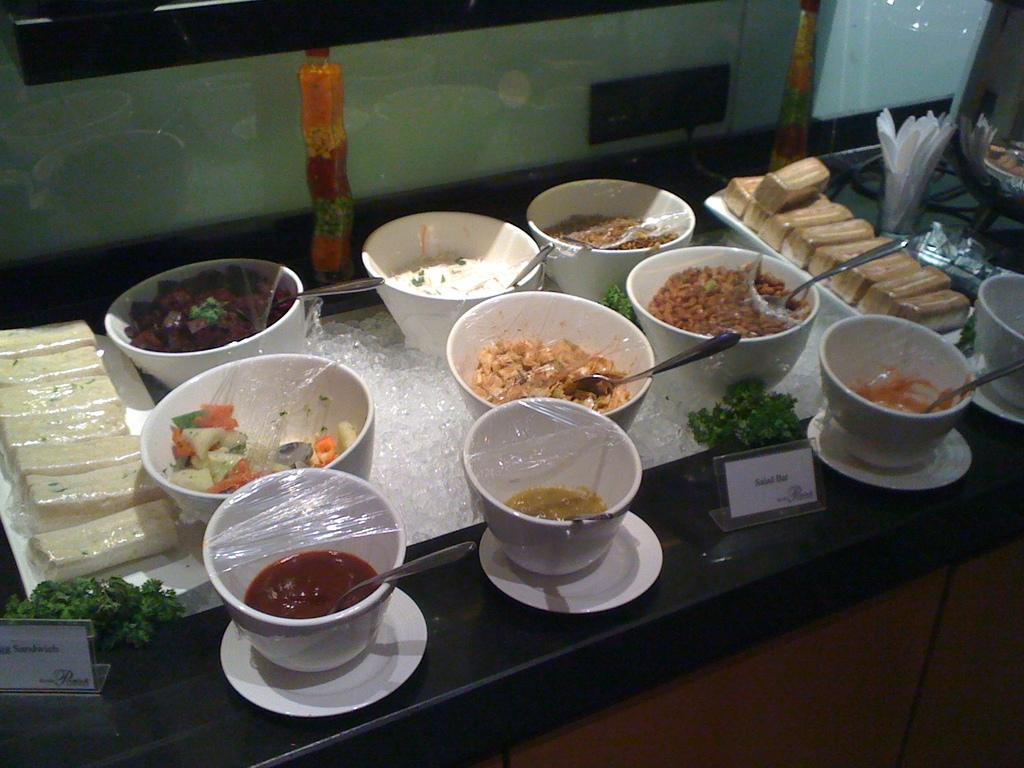In one or two sentences, can you explain what this image depicts? In the center of the image there is a table. On the table we can see bowl of food items with spoons, plates, ice cubes, boards tissue paper, glass and some objects. At the top of the image there is a wall. 